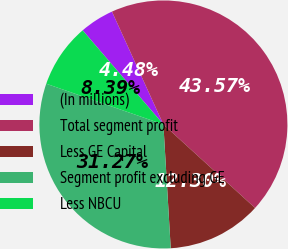<chart> <loc_0><loc_0><loc_500><loc_500><pie_chart><fcel>(In millions)<fcel>Total segment profit<fcel>Less GE Capital<fcel>Segment profit excluding GE<fcel>Less NBCU<nl><fcel>4.48%<fcel>43.57%<fcel>12.3%<fcel>31.27%<fcel>8.39%<nl></chart> 